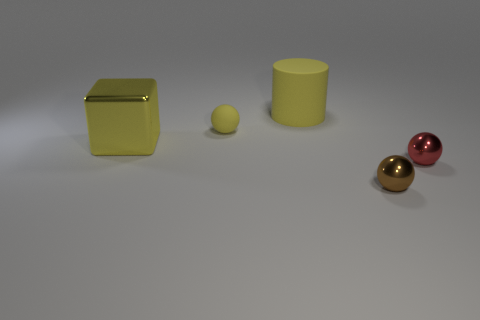Add 3 small matte things. How many objects exist? 8 Subtract all blocks. How many objects are left? 4 Subtract all blue shiny spheres. Subtract all small shiny balls. How many objects are left? 3 Add 2 cubes. How many cubes are left? 3 Add 1 blue metallic balls. How many blue metallic balls exist? 1 Subtract 0 gray cylinders. How many objects are left? 5 